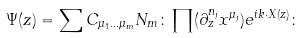<formula> <loc_0><loc_0><loc_500><loc_500>\Psi ( z ) = \sum C _ { \mu _ { 1 } \dots \mu _ { m } } N _ { m } \colon \prod ( \partial _ { z } ^ { n _ { j } } x ^ { \mu _ { j } } ) e ^ { i k \cdot X ( z ) } \colon</formula> 